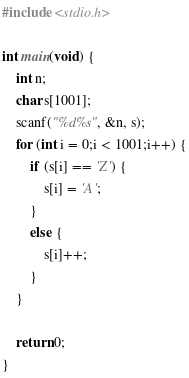Convert code to text. <code><loc_0><loc_0><loc_500><loc_500><_C_>#include <stdio.h>

int main(void) {
	int n;
	char s[1001];
	scanf("%d%s", &n, s);
	for (int i = 0;i < 1001;i++) {
		if (s[i] == 'Z') {
			s[i] = 'A';
		}
		else {
			s[i]++;
		}
	}

	return 0;
}</code> 